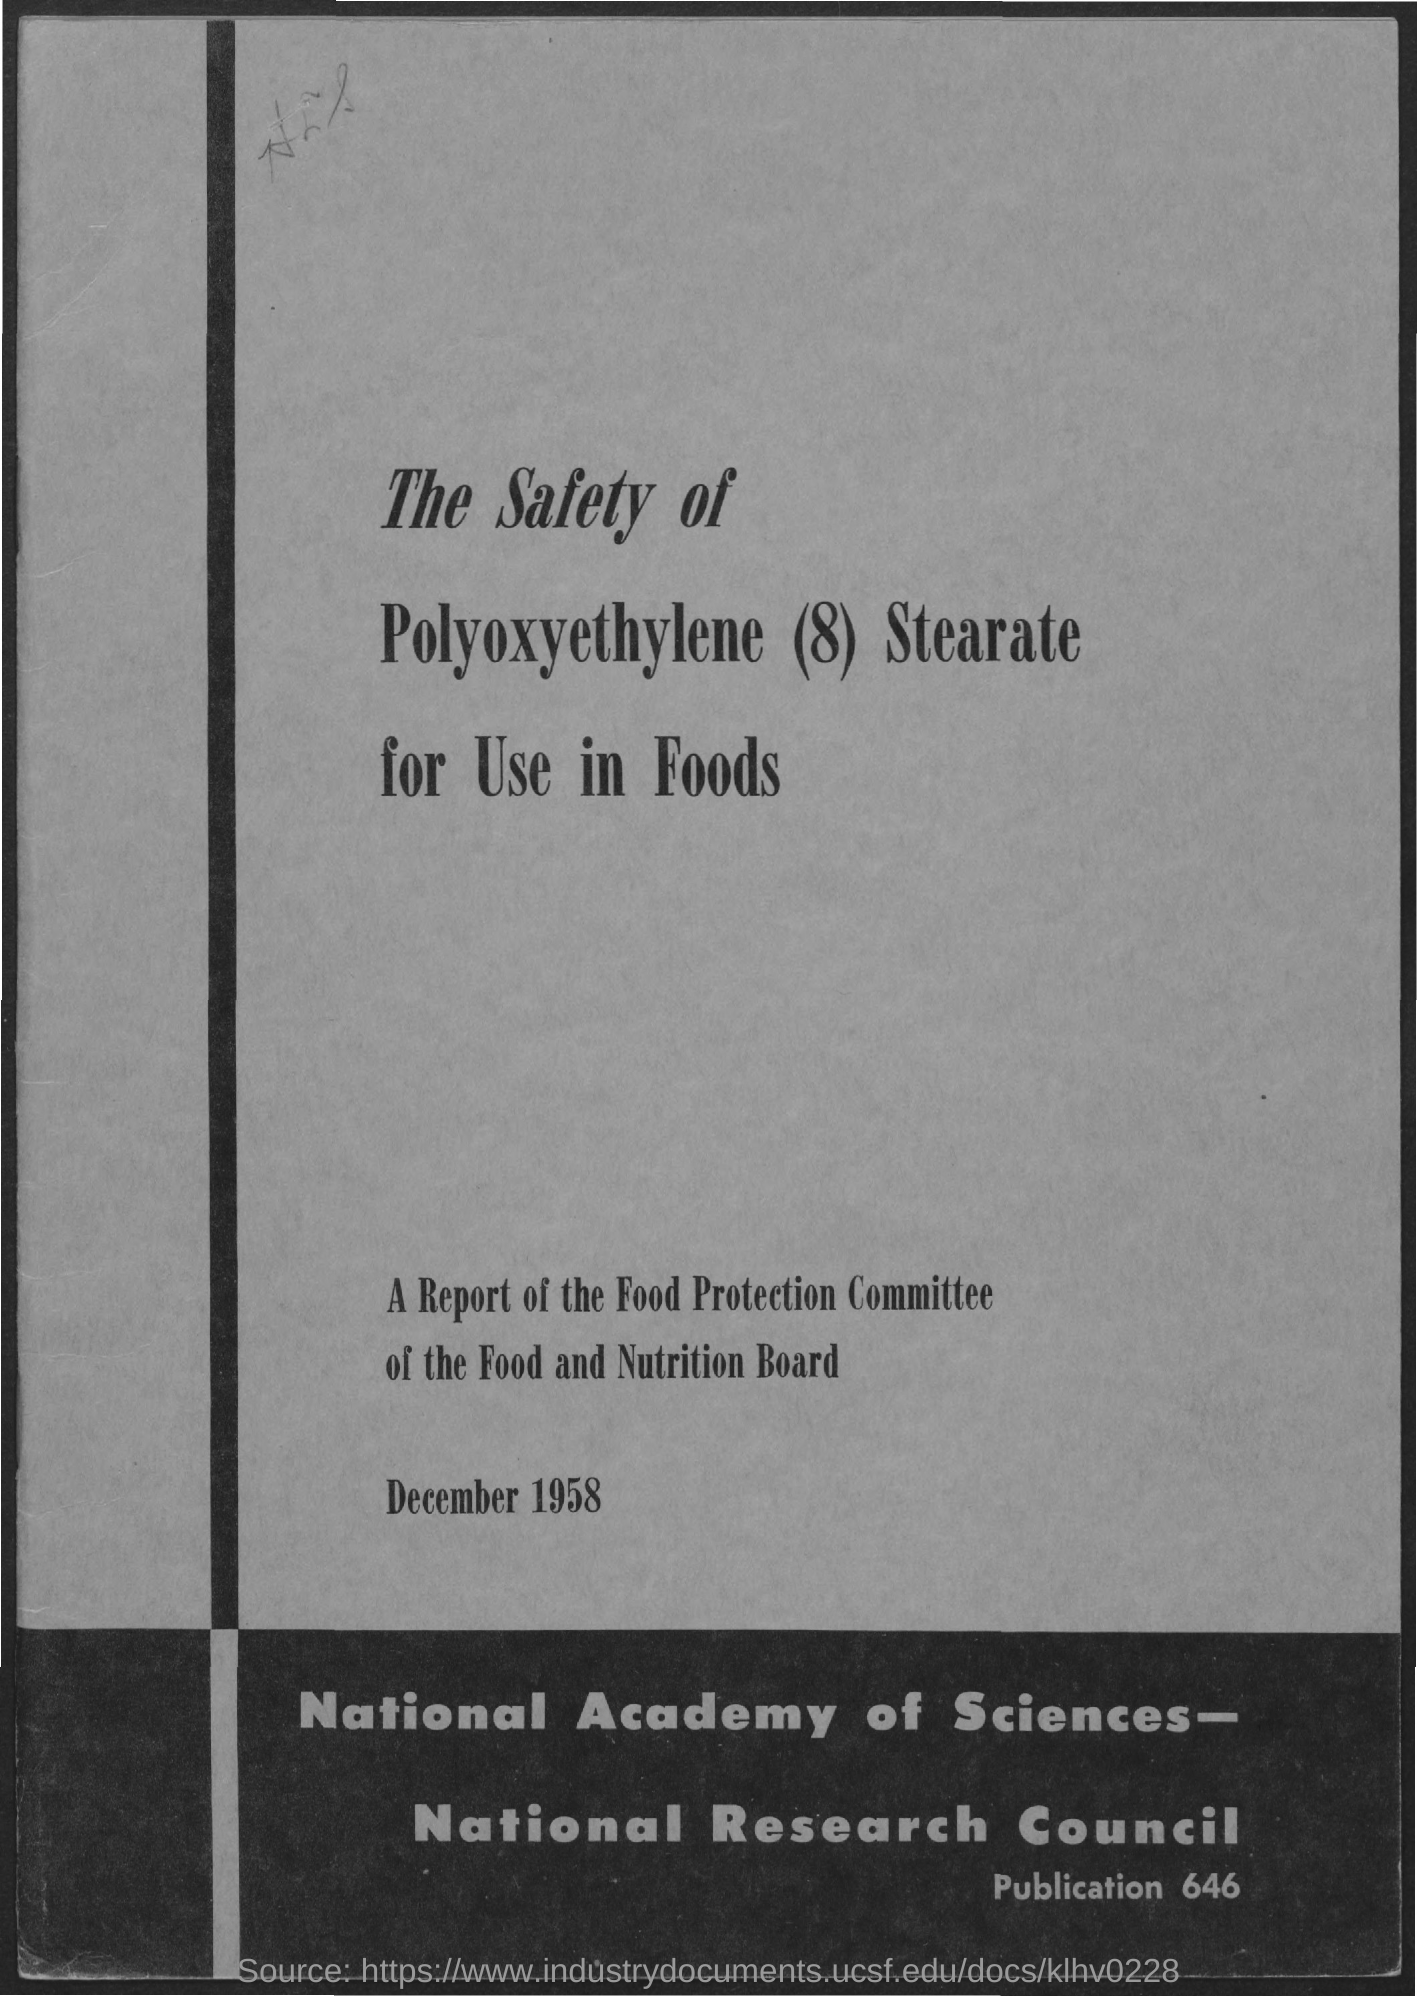Indicate a few pertinent items in this graphic. This report belongs to the Food Protection Committee. The report is dated December 1958. The number of publications is 646. The title of the page is 'The Safety of Polyoxyethylene (8) Stearate for Use in Foods.' 